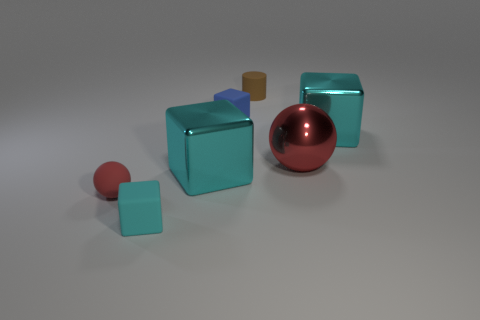What is the shape of the tiny matte thing that is the same color as the large metallic ball?
Your answer should be compact. Sphere. There is another ball that is the same color as the tiny matte ball; what material is it?
Your answer should be compact. Metal. What number of other things are there of the same color as the tiny rubber sphere?
Your answer should be compact. 1. Is the rubber cylinder the same color as the small matte ball?
Ensure brevity in your answer.  No. What number of cyan metal objects are there?
Offer a very short reply. 2. There is a cyan object that is to the right of the small cube behind the cyan rubber thing; what is its material?
Offer a very short reply. Metal. There is a blue cube that is the same size as the brown object; what material is it?
Your response must be concise. Rubber. There is a cyan metallic thing left of the brown cylinder; is it the same size as the small brown rubber cylinder?
Offer a very short reply. No. Is the shape of the tiny rubber thing that is in front of the small red matte sphere the same as  the brown rubber thing?
Your answer should be compact. No. What number of things are large purple metal cubes or blue rubber things right of the tiny rubber ball?
Your response must be concise. 1. 